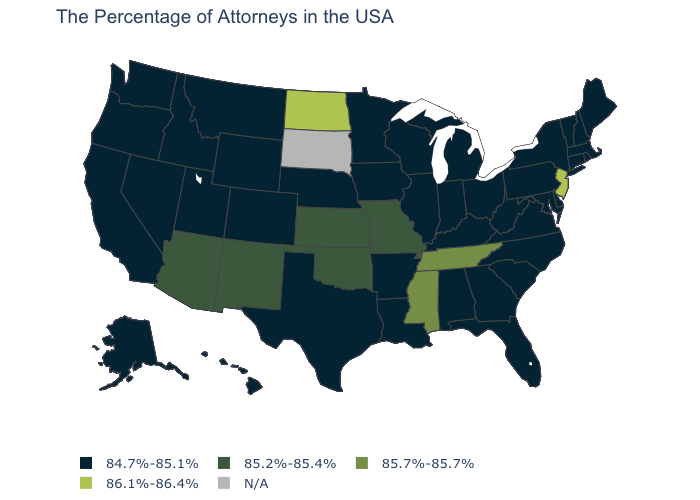Name the states that have a value in the range N/A?
Write a very short answer. South Dakota. What is the value of New Hampshire?
Be succinct. 84.7%-85.1%. Among the states that border Louisiana , does Mississippi have the highest value?
Keep it brief. Yes. What is the highest value in the USA?
Concise answer only. 86.1%-86.4%. Does New Jersey have the highest value in the Northeast?
Give a very brief answer. Yes. Name the states that have a value in the range 85.2%-85.4%?
Give a very brief answer. Missouri, Kansas, Oklahoma, New Mexico, Arizona. Which states have the lowest value in the MidWest?
Be succinct. Ohio, Michigan, Indiana, Wisconsin, Illinois, Minnesota, Iowa, Nebraska. Does the first symbol in the legend represent the smallest category?
Quick response, please. Yes. Which states hav the highest value in the South?
Be succinct. Tennessee, Mississippi. Is the legend a continuous bar?
Be succinct. No. Name the states that have a value in the range 85.7%-85.7%?
Answer briefly. Tennessee, Mississippi. Among the states that border North Dakota , which have the lowest value?
Be succinct. Minnesota, Montana. Name the states that have a value in the range 86.1%-86.4%?
Short answer required. New Jersey, North Dakota. Does the first symbol in the legend represent the smallest category?
Answer briefly. Yes. Name the states that have a value in the range 86.1%-86.4%?
Quick response, please. New Jersey, North Dakota. 